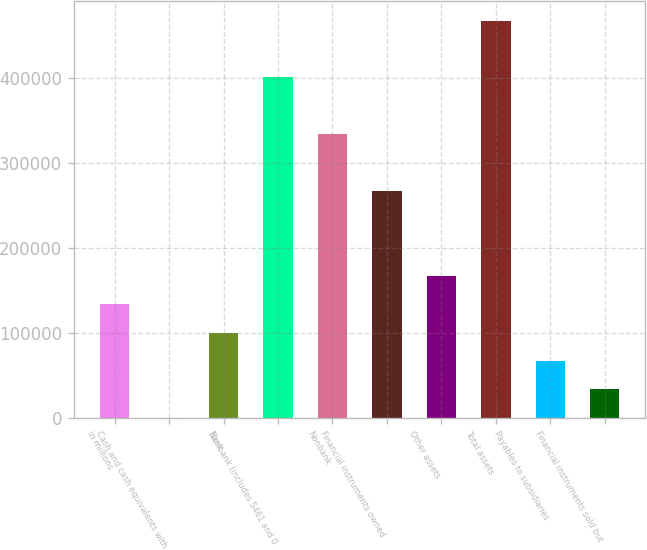<chart> <loc_0><loc_0><loc_500><loc_500><bar_chart><fcel>in millions<fcel>Cash and cash equivalents with<fcel>Bank<fcel>Nonbank (includes 5461 and 0<fcel>Nonbank<fcel>Financial instruments owned<fcel>Other assets<fcel>Total assets<fcel>Payables to subsidiaries<fcel>Financial instruments sold but<nl><fcel>133664<fcel>103<fcel>100274<fcel>400785<fcel>334005<fcel>267225<fcel>167054<fcel>467566<fcel>66883.4<fcel>33493.2<nl></chart> 